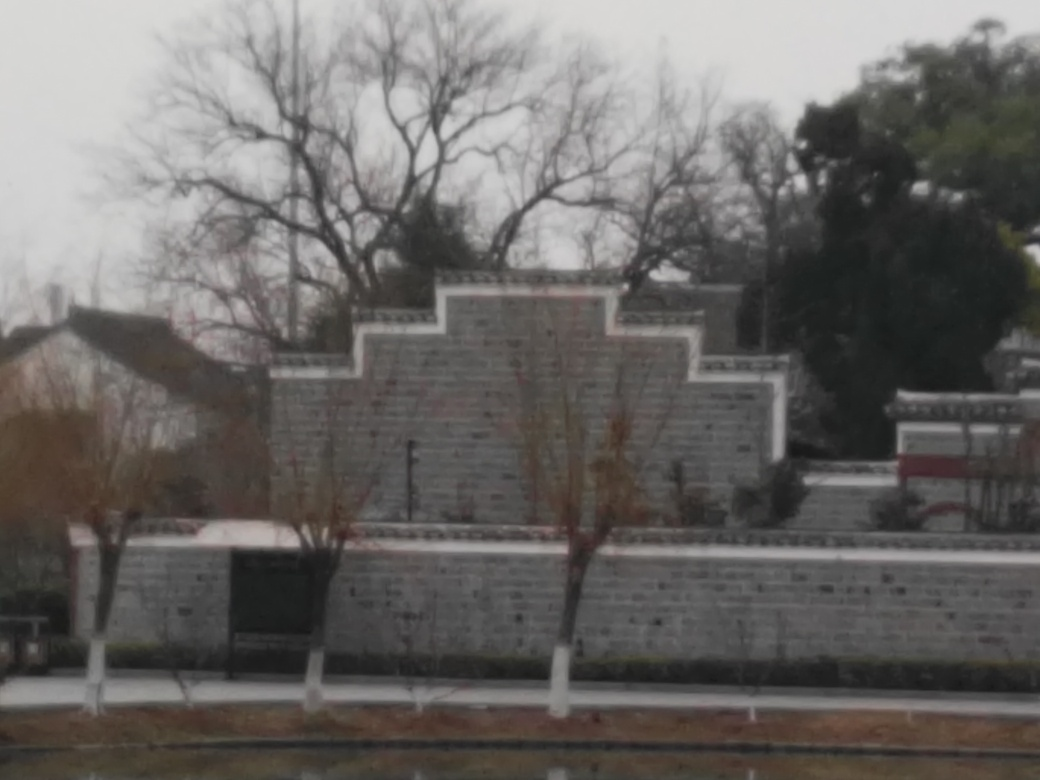What kind of weather does the image depict? The overcast sky suggests dull weather conditions, likely cold or cool, often associated with winter or a rainy day. The overall ambience is quite gray and gloomy, which points to a lack of sunshine and potential precipitation. 